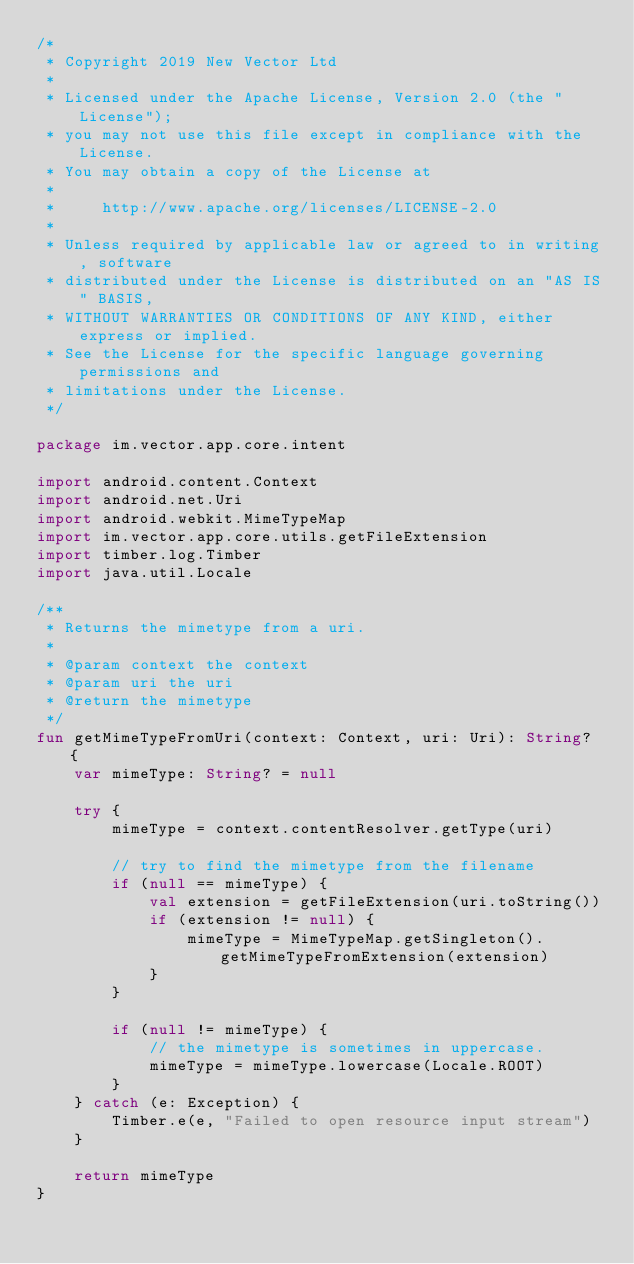<code> <loc_0><loc_0><loc_500><loc_500><_Kotlin_>/*
 * Copyright 2019 New Vector Ltd
 *
 * Licensed under the Apache License, Version 2.0 (the "License");
 * you may not use this file except in compliance with the License.
 * You may obtain a copy of the License at
 *
 *     http://www.apache.org/licenses/LICENSE-2.0
 *
 * Unless required by applicable law or agreed to in writing, software
 * distributed under the License is distributed on an "AS IS" BASIS,
 * WITHOUT WARRANTIES OR CONDITIONS OF ANY KIND, either express or implied.
 * See the License for the specific language governing permissions and
 * limitations under the License.
 */

package im.vector.app.core.intent

import android.content.Context
import android.net.Uri
import android.webkit.MimeTypeMap
import im.vector.app.core.utils.getFileExtension
import timber.log.Timber
import java.util.Locale

/**
 * Returns the mimetype from a uri.
 *
 * @param context the context
 * @param uri the uri
 * @return the mimetype
 */
fun getMimeTypeFromUri(context: Context, uri: Uri): String? {
    var mimeType: String? = null

    try {
        mimeType = context.contentResolver.getType(uri)

        // try to find the mimetype from the filename
        if (null == mimeType) {
            val extension = getFileExtension(uri.toString())
            if (extension != null) {
                mimeType = MimeTypeMap.getSingleton().getMimeTypeFromExtension(extension)
            }
        }

        if (null != mimeType) {
            // the mimetype is sometimes in uppercase.
            mimeType = mimeType.lowercase(Locale.ROOT)
        }
    } catch (e: Exception) {
        Timber.e(e, "Failed to open resource input stream")
    }

    return mimeType
}
</code> 